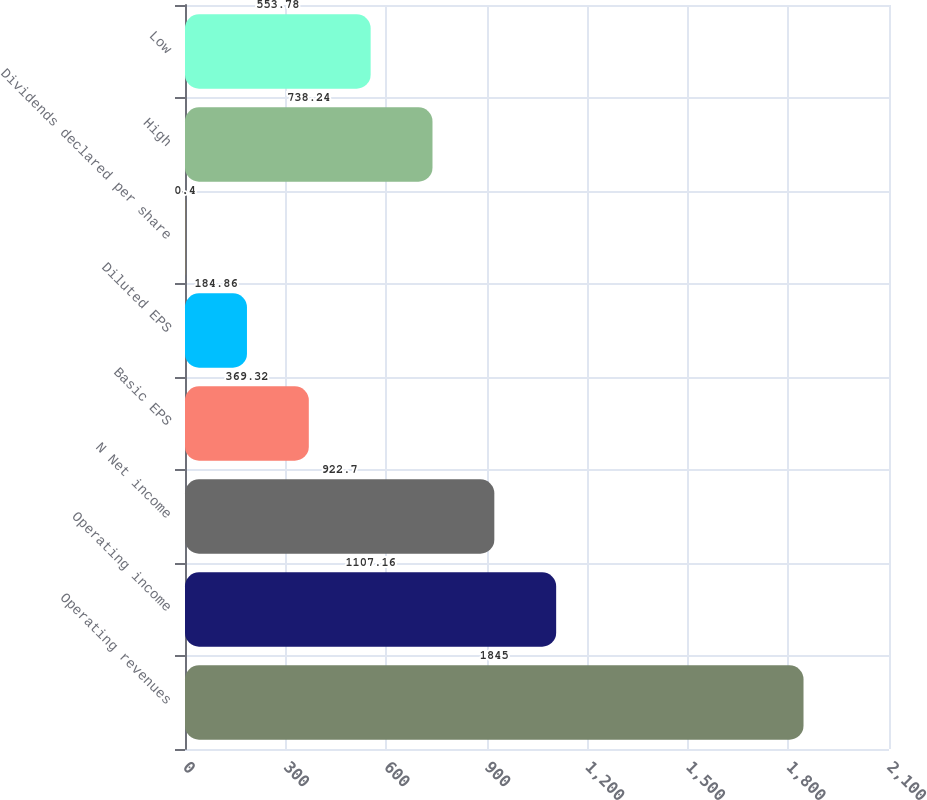Convert chart to OTSL. <chart><loc_0><loc_0><loc_500><loc_500><bar_chart><fcel>Operating revenues<fcel>Operating income<fcel>N Net income<fcel>Basic EPS<fcel>Diluted EPS<fcel>Dividends declared per share<fcel>High<fcel>Low<nl><fcel>1845<fcel>1107.16<fcel>922.7<fcel>369.32<fcel>184.86<fcel>0.4<fcel>738.24<fcel>553.78<nl></chart> 